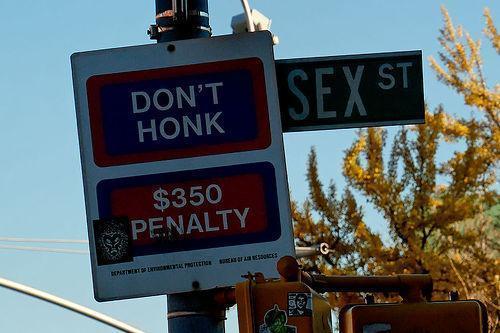How many signs are there?
Give a very brief answer. 2. 